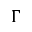<formula> <loc_0><loc_0><loc_500><loc_500>\Gamma</formula> 